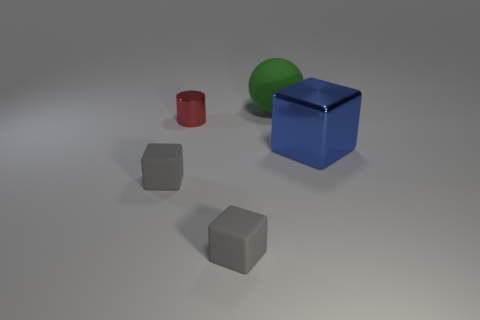There is a matte block on the right side of the small red metal cylinder; does it have the same color as the matte cube left of the cylinder?
Ensure brevity in your answer.  Yes. Are the big object that is in front of the sphere and the gray thing to the right of the small cylinder made of the same material?
Your answer should be very brief. No. Are there the same number of small red metal cylinders in front of the large matte sphere and gray rubber cubes that are behind the blue thing?
Your answer should be compact. No. What number of other things are the same color as the big metal object?
Offer a very short reply. 0. How many matte objects are either tiny gray objects or cylinders?
Your response must be concise. 2. Does the tiny gray object that is to the right of the metal cylinder have the same shape as the object to the left of the red cylinder?
Your response must be concise. Yes. What number of small gray objects are left of the red shiny object?
Your answer should be very brief. 1. Are there any blue cubes that have the same material as the tiny red cylinder?
Your answer should be compact. Yes. What is the material of the blue block that is the same size as the green thing?
Your answer should be compact. Metal. Does the cylinder have the same material as the green sphere?
Provide a succinct answer. No. 